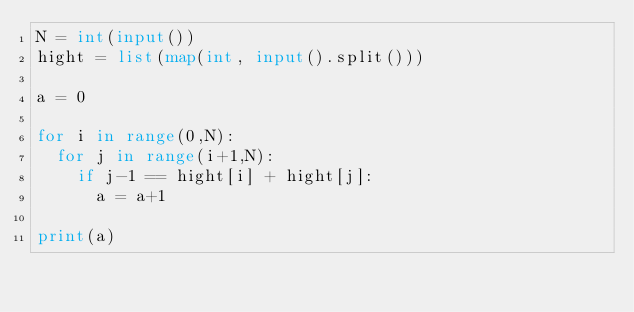<code> <loc_0><loc_0><loc_500><loc_500><_Python_>N = int(input())
hight = list(map(int, input().split()))

a = 0

for i in range(0,N):
  for j in range(i+1,N):
    if j-1 == hight[i] + hight[j]:
      a = a+1

print(a)</code> 